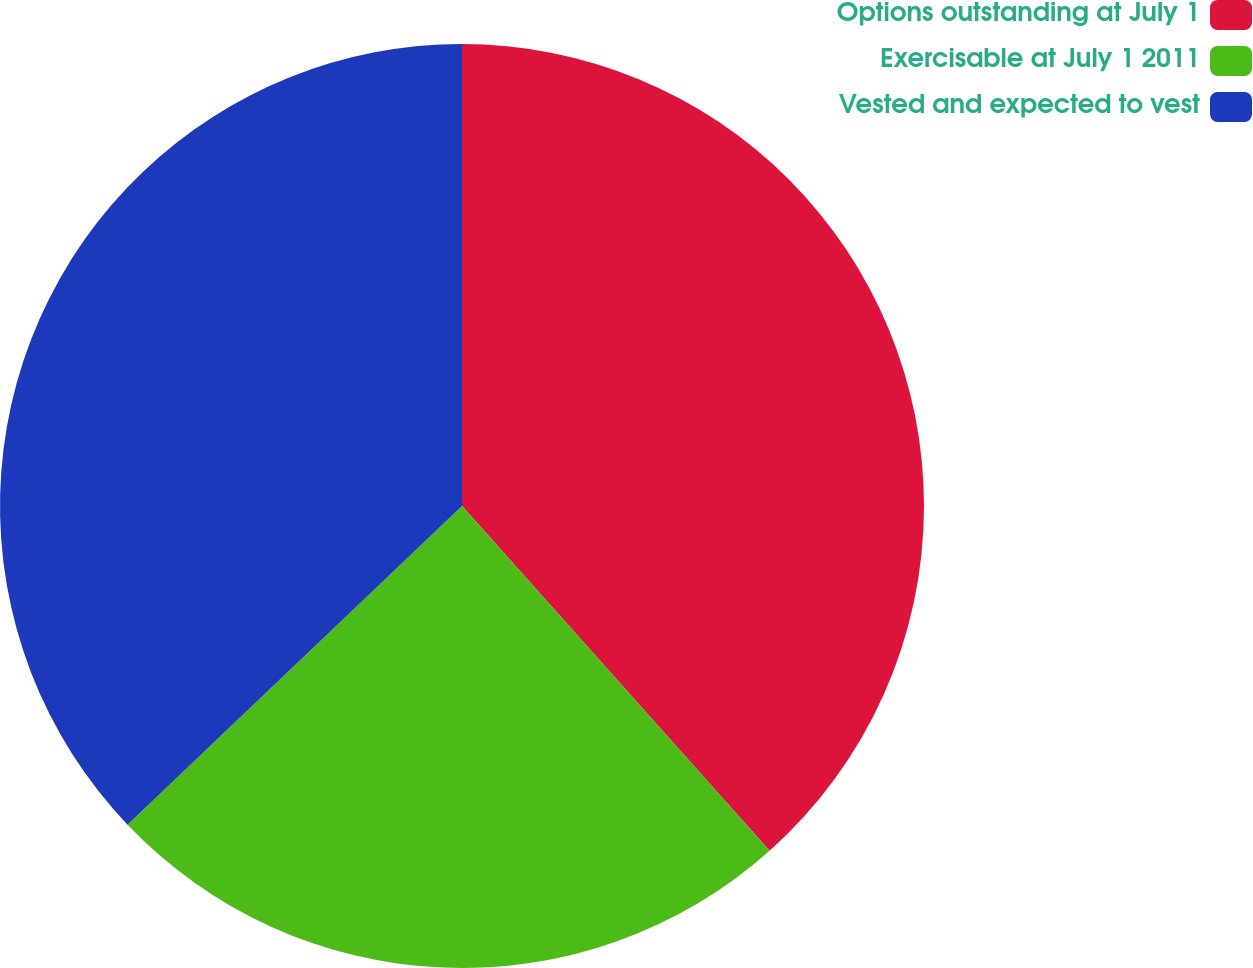Convert chart to OTSL. <chart><loc_0><loc_0><loc_500><loc_500><pie_chart><fcel>Options outstanding at July 1<fcel>Exercisable at July 1 2011<fcel>Vested and expected to vest<nl><fcel>38.4%<fcel>24.48%<fcel>37.11%<nl></chart> 